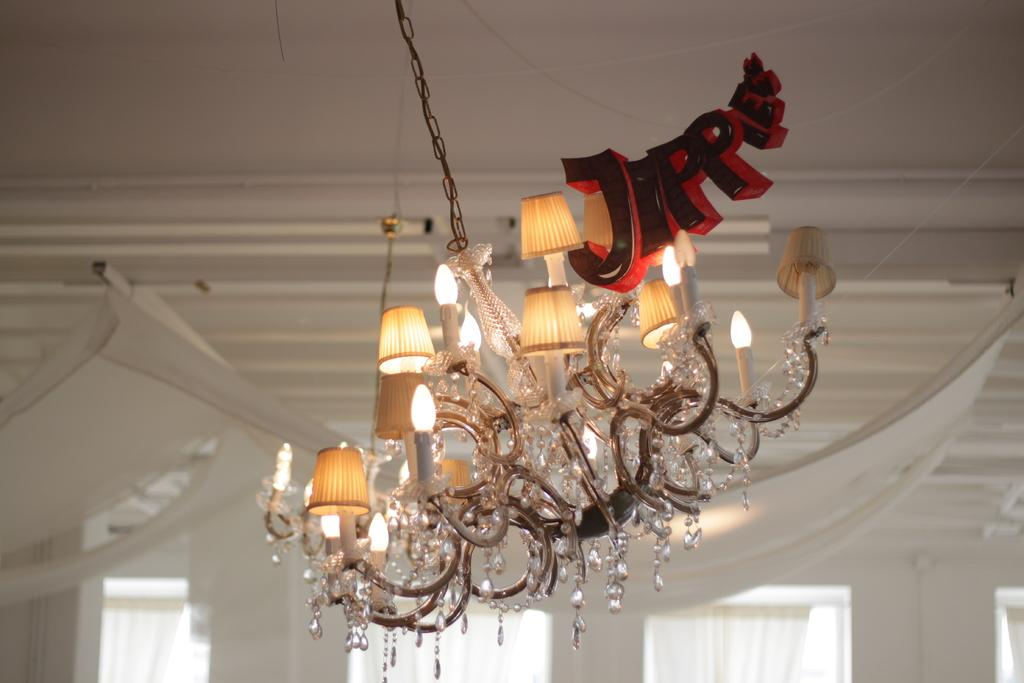What can be seen in the image that provides illumination? There are lights in the image. What type of window treatment is present in the image? There are white color curtains at the bottom of the windows in the image. What type of badge is being worn by the person in the image? There is no person present in the image, so it is not possible to determine if they are wearing a badge. How does the sweater expand to accommodate the person's movements in the image? There is no sweater or person present in the image, so it is not possible to determine how a sweater might expand. 